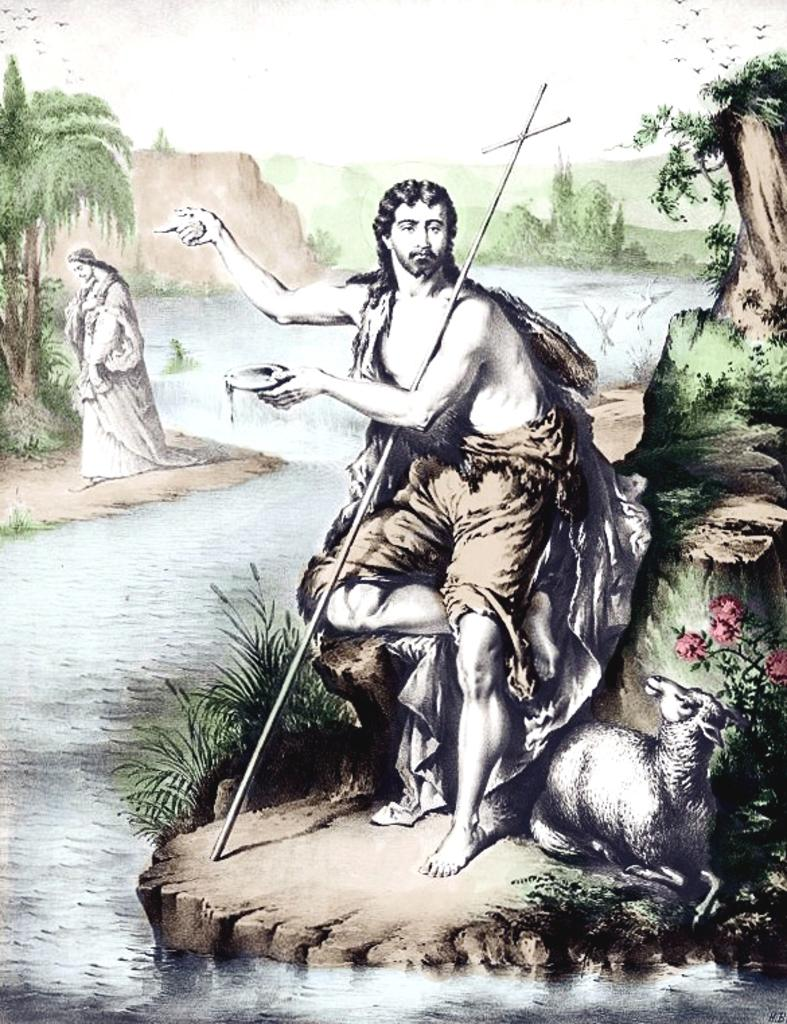What type of art can be seen in the image? There is art of people, an animal, plants, trees, and birds in the image. What natural elements are visible in the image? Water and ground are visible in the image. What type of match is being played in the image? There is no match being played in the image; it features art of people, animals, plants, trees, and birds. Can you tell me the account number of the artist who created the image? There is no account number provided, as we are only looking at the image and not the artist's personal information. 